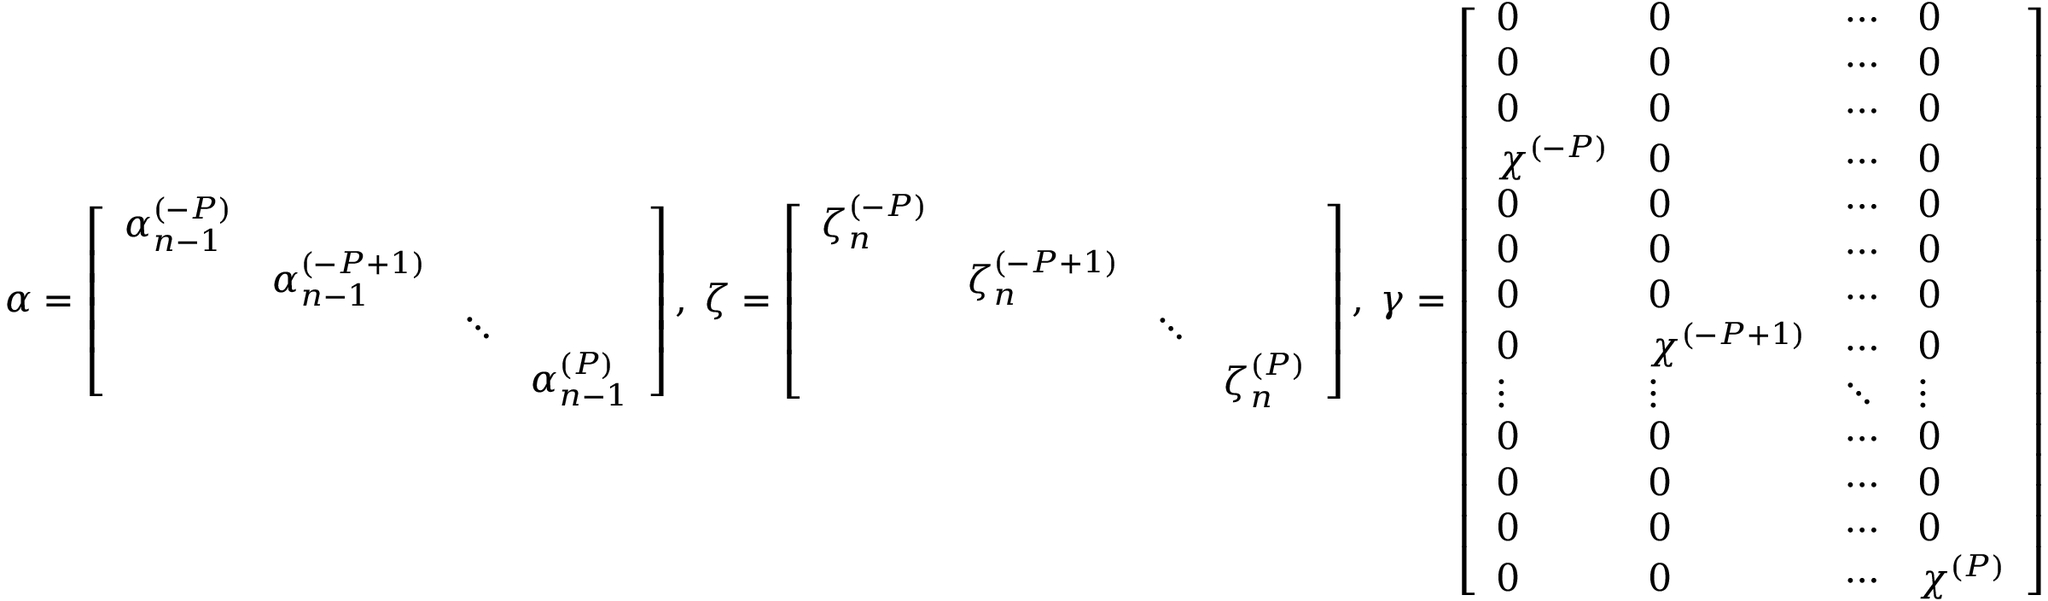<formula> <loc_0><loc_0><loc_500><loc_500>\boldsymbol \alpha = \left [ \begin{array} { c c c c } { \boldsymbol \alpha _ { n - 1 } ^ { ( - P ) } } & & & \\ & { \boldsymbol \alpha _ { n - 1 } ^ { ( - P + 1 ) } } & & \\ & & { \ddots } & \\ & & & { \boldsymbol \alpha _ { n - 1 } ^ { ( P ) } } \end{array} \right ] , \, \boldsymbol \zeta = \left [ \begin{array} { c c c c } { \boldsymbol \zeta _ { n } ^ { ( - P ) } } & & & \\ & { \boldsymbol \zeta _ { n } ^ { ( - P + 1 ) } } & & \\ & & { \ddots } & \\ & & & { \boldsymbol \zeta _ { n } ^ { ( P ) } } \end{array} \right ] , \, \boldsymbol \gamma = \left [ \begin{array} { l l l l } { 0 } & { 0 } & { \cdots } & { 0 } \\ { 0 } & { 0 } & { \cdots } & { 0 } \\ { 0 } & { 0 } & { \cdots } & { 0 } \\ { \chi ^ { ( - P ) } } & { 0 } & { \cdots } & { 0 } \\ { 0 } & { 0 } & { \cdots } & { 0 } \\ { 0 } & { 0 } & { \cdots } & { 0 } \\ { 0 } & { 0 } & { \cdots } & { 0 } \\ { 0 } & { \chi ^ { ( - P + 1 ) } } & { \cdots } & { 0 } \\ { \vdots } & { \vdots } & { \ddots } & { \vdots } \\ { 0 } & { 0 } & { \cdots } & { 0 } \\ { 0 } & { 0 } & { \cdots } & { 0 } \\ { 0 } & { 0 } & { \cdots } & { 0 } \\ { 0 } & { 0 } & { \cdots } & { \chi ^ { ( P ) } } \end{array} \right ]</formula> 